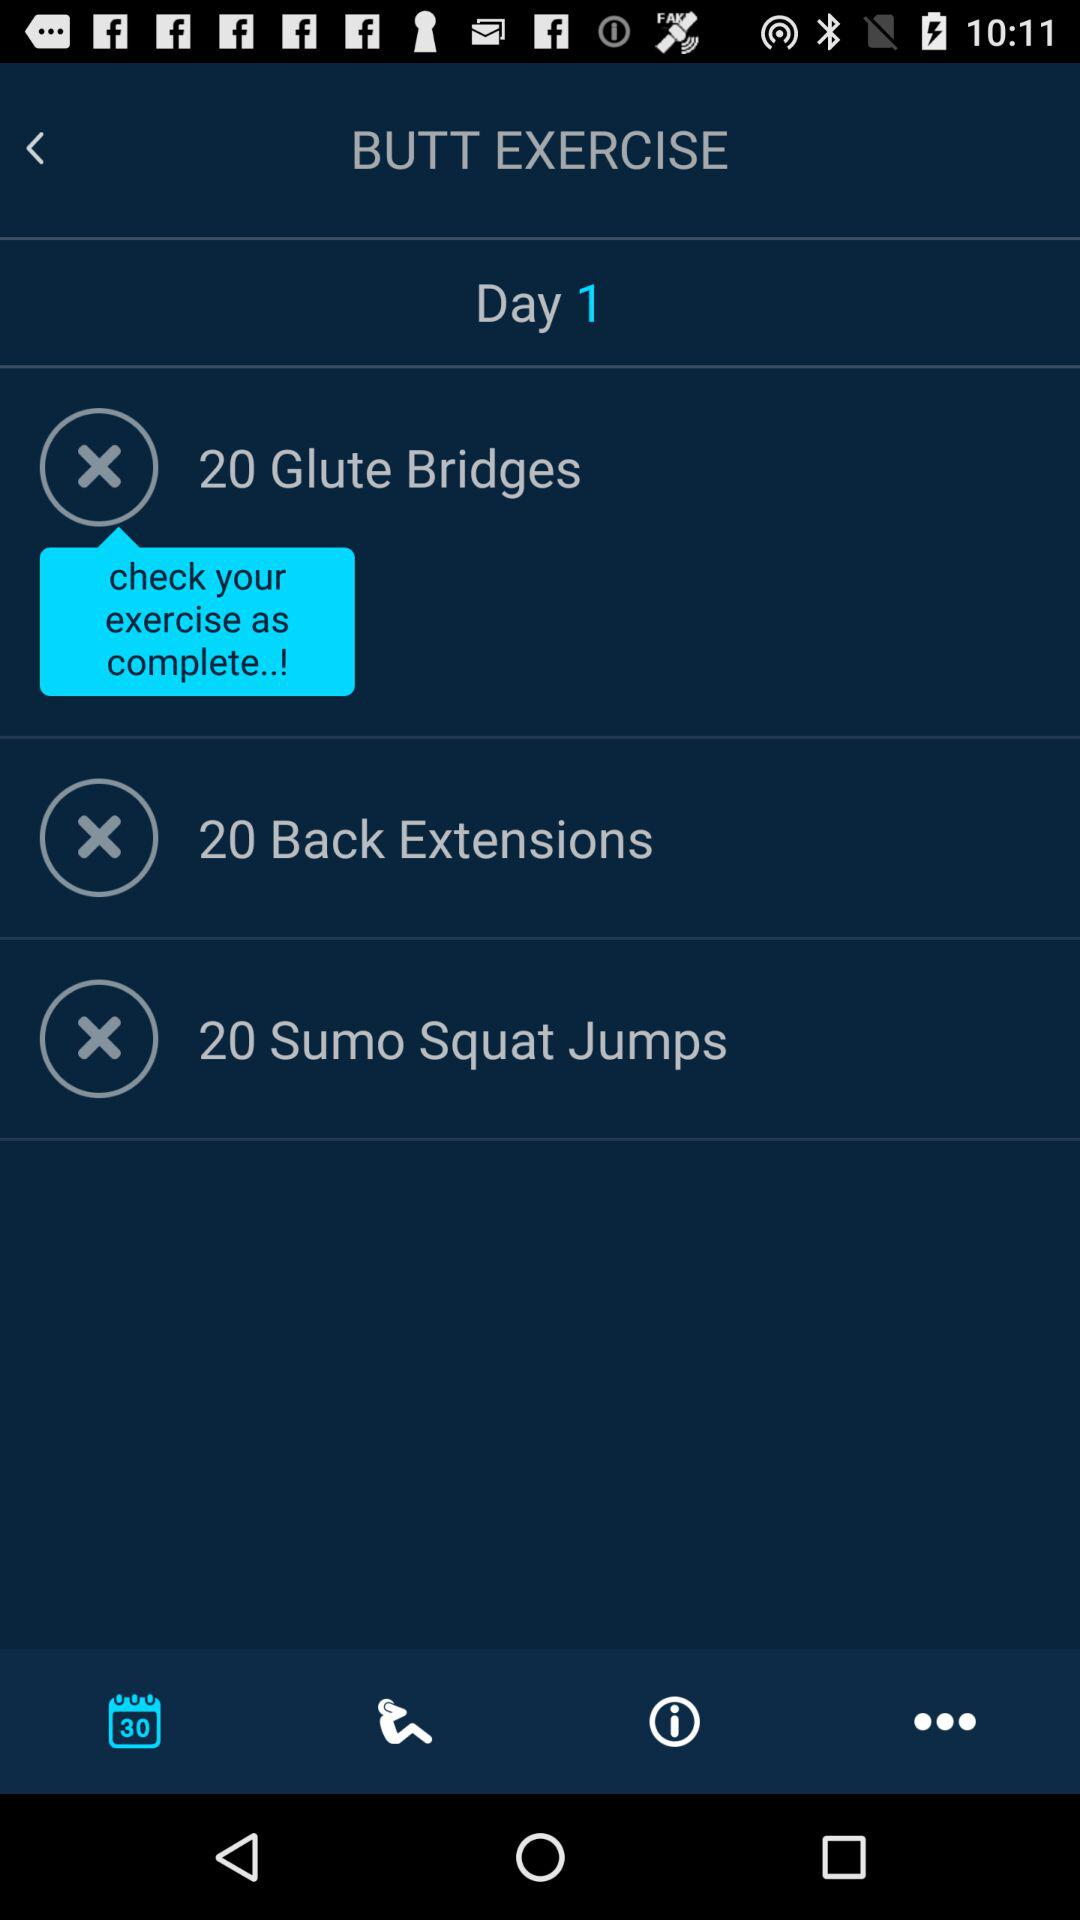What is the mentioned day number? The mentioned day number is 1. 